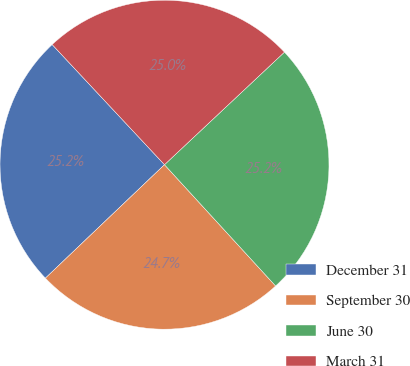Convert chart. <chart><loc_0><loc_0><loc_500><loc_500><pie_chart><fcel>December 31<fcel>September 30<fcel>June 30<fcel>March 31<nl><fcel>25.15%<fcel>24.69%<fcel>25.19%<fcel>24.97%<nl></chart> 